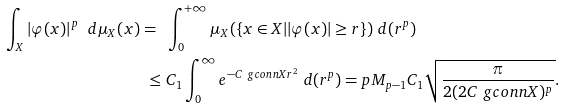<formula> <loc_0><loc_0><loc_500><loc_500>\int _ { X } | \varphi ( x ) | ^ { p } \ d \mu _ { X } ( x ) = \ & \int _ { 0 } ^ { + \infty } \mu _ { X } ( \{ x \in X | | \varphi ( x ) | \geq r \} ) \ d ( r ^ { p } ) \\ \leq \ & C _ { 1 } \int _ { 0 } ^ { \infty } e ^ { - C \ g c o n n { X } r ^ { 2 } } \ d ( r ^ { p } ) = p M _ { p - 1 } C _ { 1 } \sqrt { \frac { \pi } { 2 ( 2 C \ g c o n n { X } ) ^ { p } } } .</formula> 